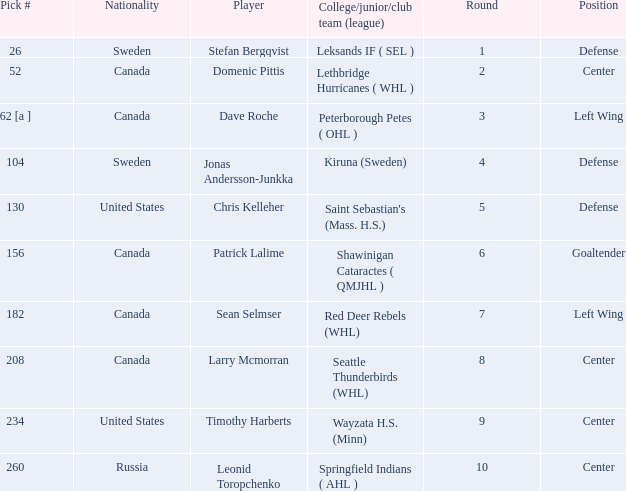What is the pick number for round 2? 52.0. 